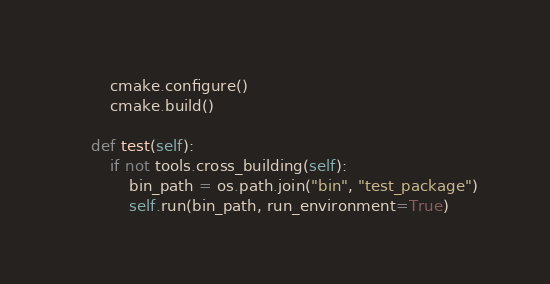Convert code to text. <code><loc_0><loc_0><loc_500><loc_500><_Python_>        cmake.configure()
        cmake.build()

    def test(self):
        if not tools.cross_building(self):
            bin_path = os.path.join("bin", "test_package")
            self.run(bin_path, run_environment=True)
</code> 